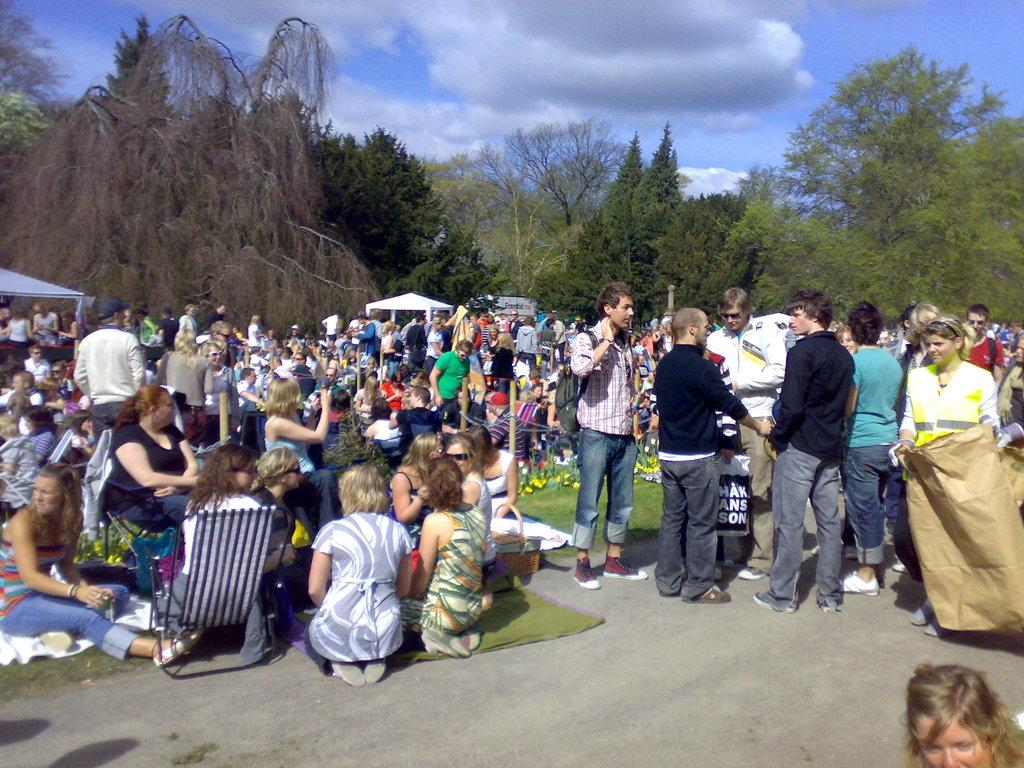How many people are in the image? There are people in the image, but the exact number is not specified. What type of clothing can be seen in the image? There are clothes visible in the image. What is the purpose of the basket in the image? The purpose of the basket in the image is not specified. What type of flowers are present in the image? There are flowers in the image, but the specific type is not mentioned. What are the tents used for in the image? The purpose of the tents in the image is not specified. What type of chairs are in the image? The type of chairs in the image is not specified. What objects can be seen in the image? There are objects in the image, but their specific nature is not mentioned. What can be seen in the background of the image? There are trees and sky visible in the background of the image. What is the weather like in the image? The presence of clouds in the sky suggests that it might be partly cloudy. Can you see a spy wearing a scarf in the image? There is no mention of a spy or a scarf in the image. How many elbows are visible in the image? The number of elbows visible in the image is not specified, and elbows are not explicitly mentioned in the facts provided. 